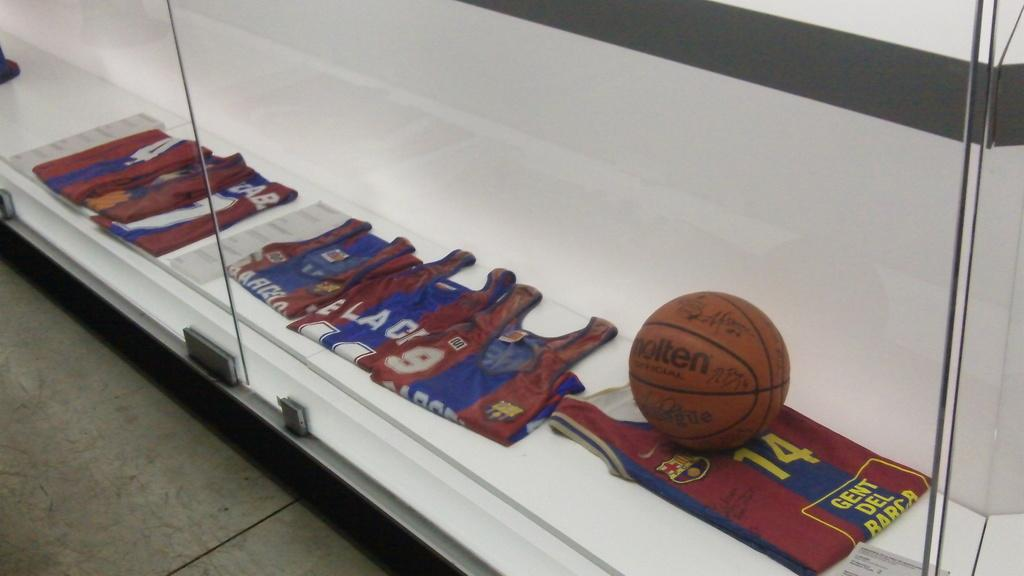Provide a one-sentence caption for the provided image. A glass display case holds several jerseys including a number 14 jersey and a basketball. 